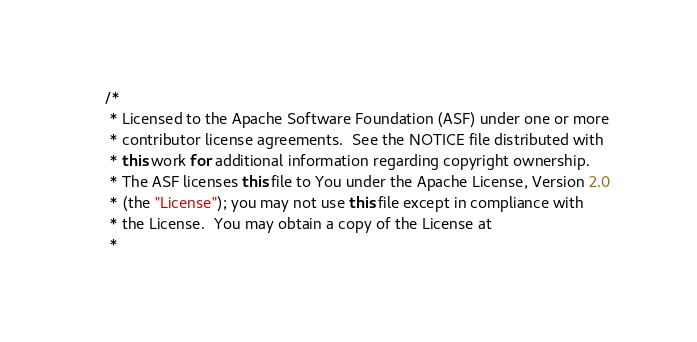Convert code to text. <code><loc_0><loc_0><loc_500><loc_500><_Java_>/*
 * Licensed to the Apache Software Foundation (ASF) under one or more
 * contributor license agreements.  See the NOTICE file distributed with
 * this work for additional information regarding copyright ownership.
 * The ASF licenses this file to You under the Apache License, Version 2.0
 * (the "License"); you may not use this file except in compliance with
 * the License.  You may obtain a copy of the License at
 *</code> 